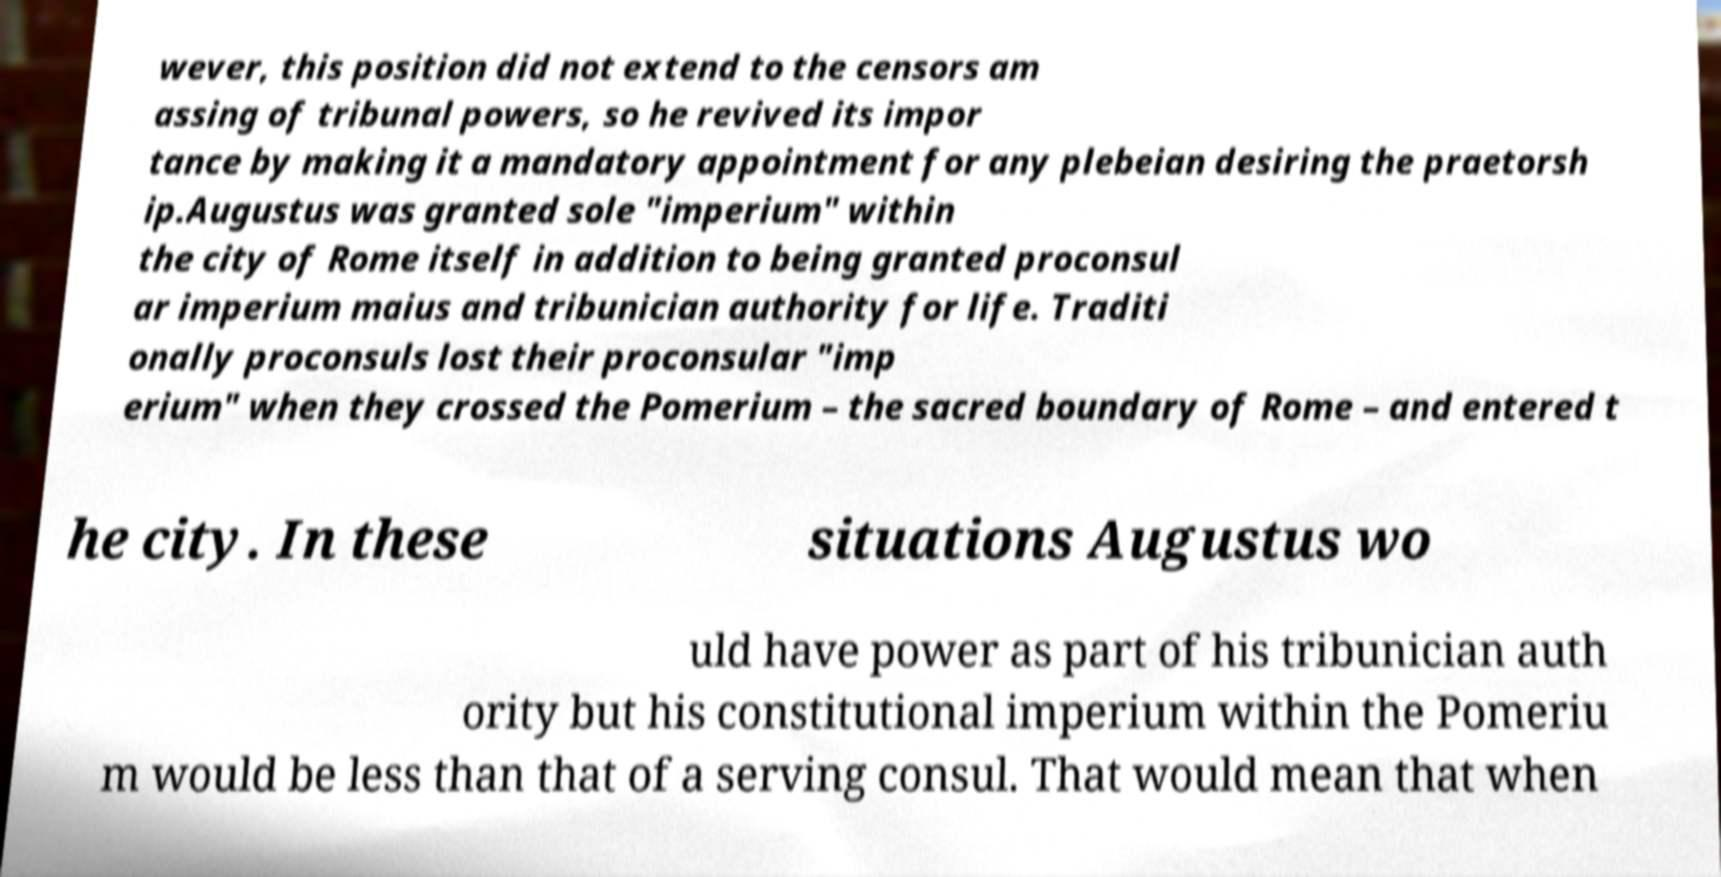Could you assist in decoding the text presented in this image and type it out clearly? wever, this position did not extend to the censors am assing of tribunal powers, so he revived its impor tance by making it a mandatory appointment for any plebeian desiring the praetorsh ip.Augustus was granted sole "imperium" within the city of Rome itself in addition to being granted proconsul ar imperium maius and tribunician authority for life. Traditi onally proconsuls lost their proconsular "imp erium" when they crossed the Pomerium – the sacred boundary of Rome – and entered t he city. In these situations Augustus wo uld have power as part of his tribunician auth ority but his constitutional imperium within the Pomeriu m would be less than that of a serving consul. That would mean that when 